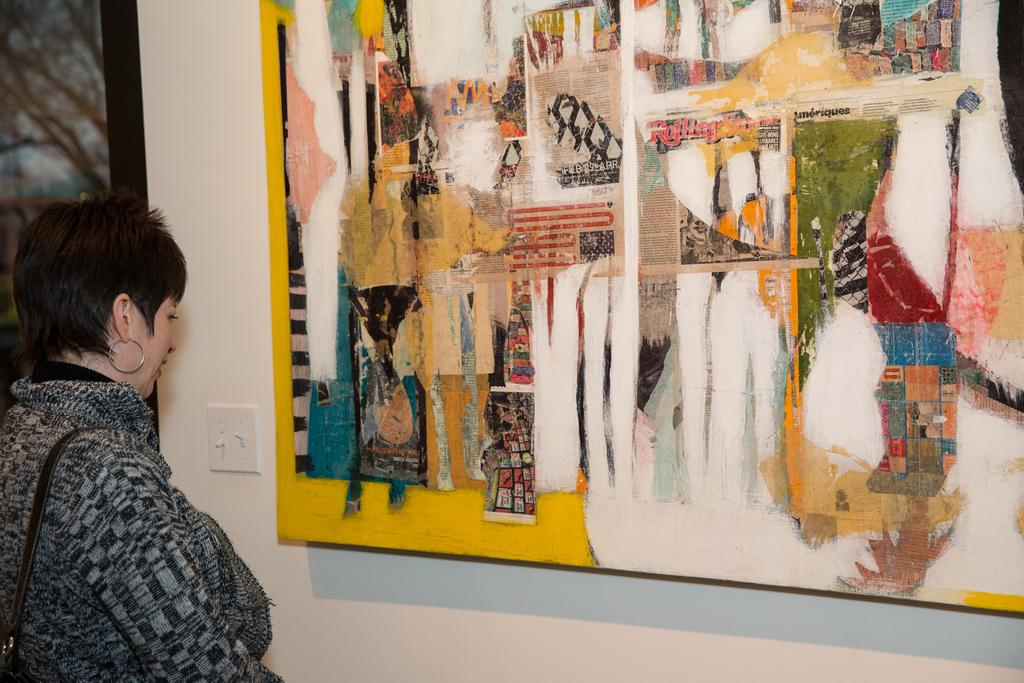What is the main subject of the image? The main subject of the image is a woman standing. What is the woman wearing in the image? The woman is wearing a strap in the image. What objects are in front of the woman? There are painting boards in front of the woman. What can be seen on the wall in the image? There is a switch board on the wall in the image. How many kittens are playing on the hill in the image? There are no kittens or hills present in the image. 